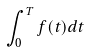Convert formula to latex. <formula><loc_0><loc_0><loc_500><loc_500>\int _ { 0 } ^ { T } f ( t ) d t</formula> 